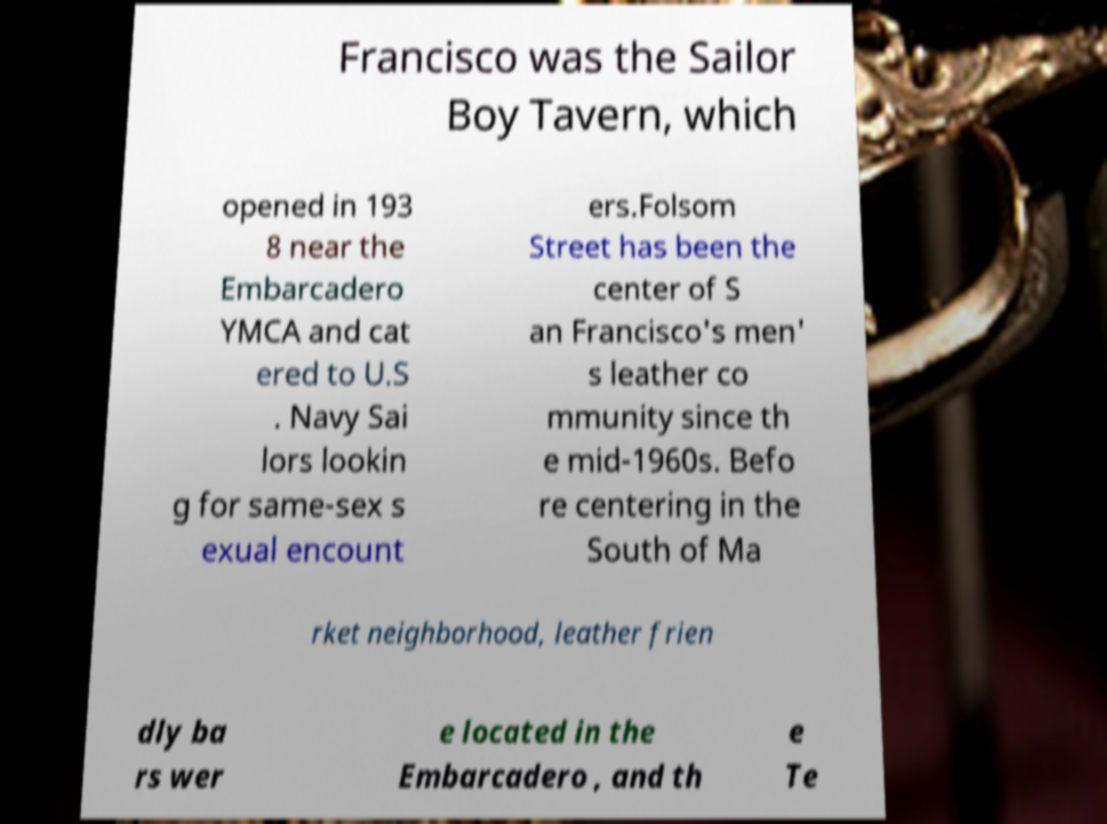Could you extract and type out the text from this image? Francisco was the Sailor Boy Tavern, which opened in 193 8 near the Embarcadero YMCA and cat ered to U.S . Navy Sai lors lookin g for same-sex s exual encount ers.Folsom Street has been the center of S an Francisco's men' s leather co mmunity since th e mid-1960s. Befo re centering in the South of Ma rket neighborhood, leather frien dly ba rs wer e located in the Embarcadero , and th e Te 